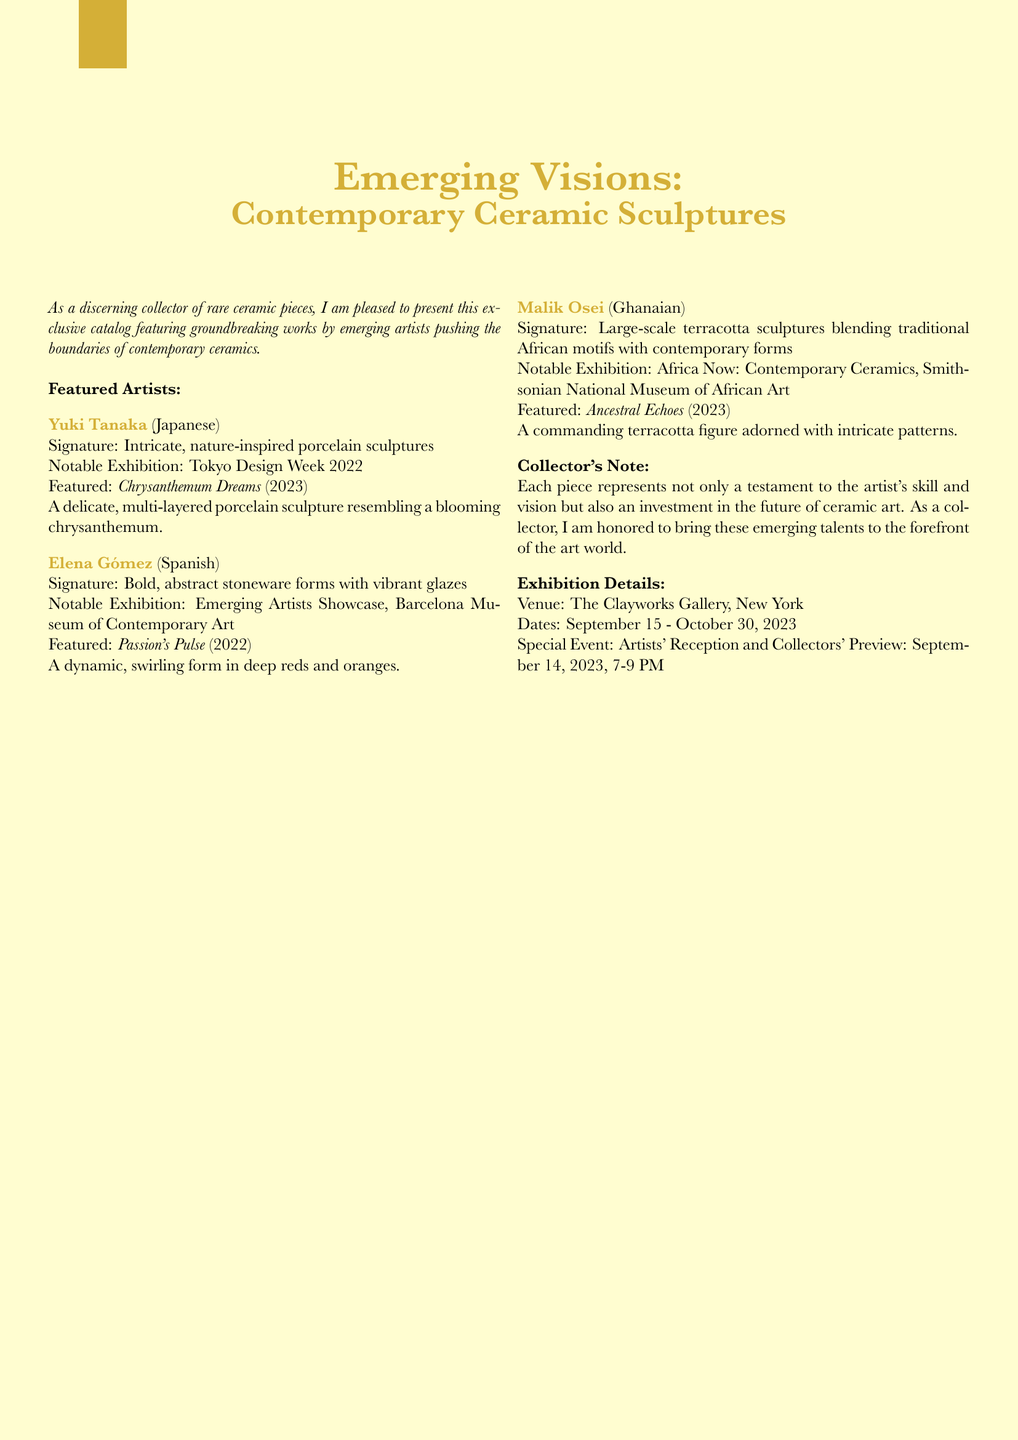What is the title of the catalog? The title of the catalog is prominently displayed at the beginning and is "Emerging Visions: Contemporary Ceramic Sculptures."
Answer: Emerging Visions: Contemporary Ceramic Sculptures Who is the artist of the sculpture "Chrysanthemum Dreams"? The artist of "Chrysanthemum Dreams" is mentioned in the featured artists section.
Answer: Yuki Tanaka What type of materials does Elena Gómez use? The materials used by Elena Gómez are specified under her profile, describing her signature style.
Answer: Stoneware When is the Artists' Reception and Collectors' Preview event? The date of the special event is listed in the exhibition details section.
Answer: September 14, 2023 How many featured artists are mentioned in the document? The number of featured artists can be counted from the section where they are listed.
Answer: Three Which exhibition did Malik Osei participate in? The notable exhibition for Malik Osei is noted, which he participated in with his work.
Answer: Africa Now: Contemporary Ceramics What is the venue of the exhibition? The location of the exhibition is stated in the exhibition details section.
Answer: The Clayworks Gallery, New York What is the signature style of Yuki Tanaka? The signature style of Yuki Tanaka is described in the artist's profile section.
Answer: Intricate, nature-inspired porcelain sculptures 